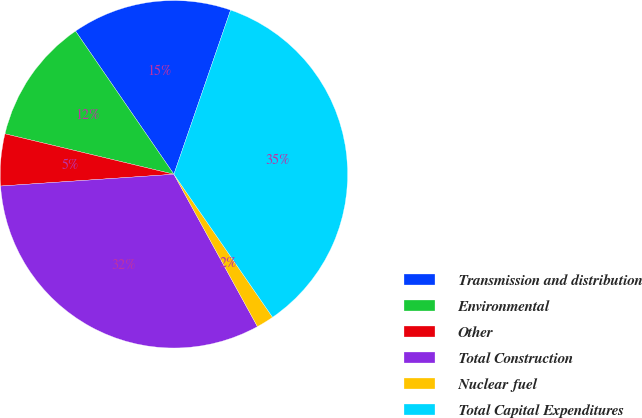Convert chart. <chart><loc_0><loc_0><loc_500><loc_500><pie_chart><fcel>Transmission and distribution<fcel>Environmental<fcel>Other<fcel>Total Construction<fcel>Nuclear fuel<fcel>Total Capital Expenditures<nl><fcel>14.87%<fcel>11.68%<fcel>4.82%<fcel>31.9%<fcel>1.63%<fcel>35.09%<nl></chart> 